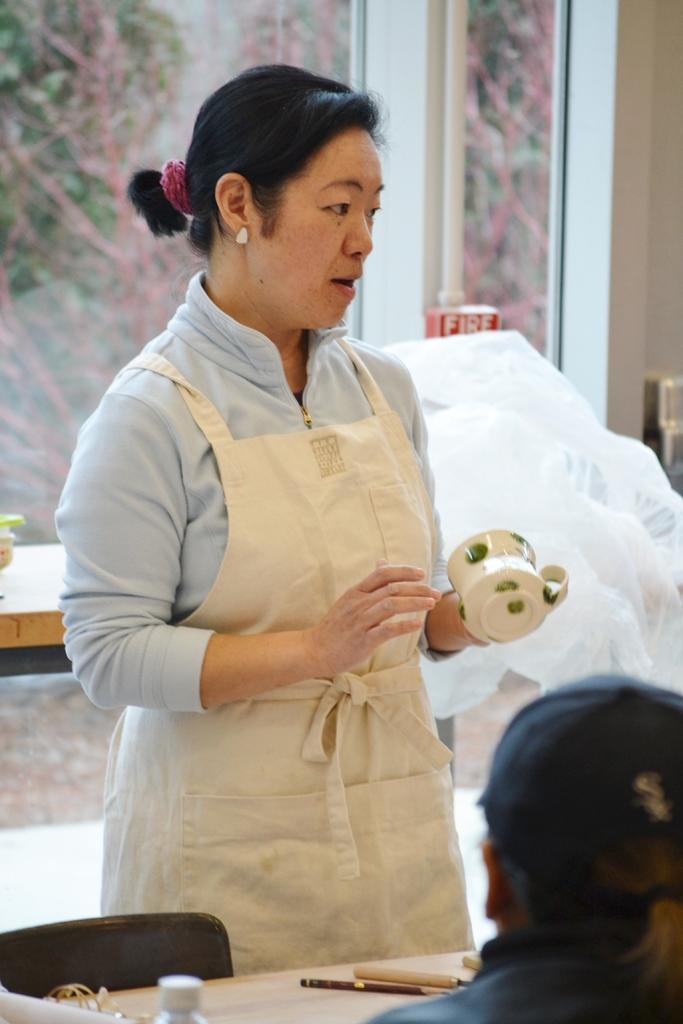Can you describe this image briefly? In this image In the middle there is a woman her hair is short she is holding a cup in front of her there is a table, chair and a person. In the background there is a window, glass and wall. 